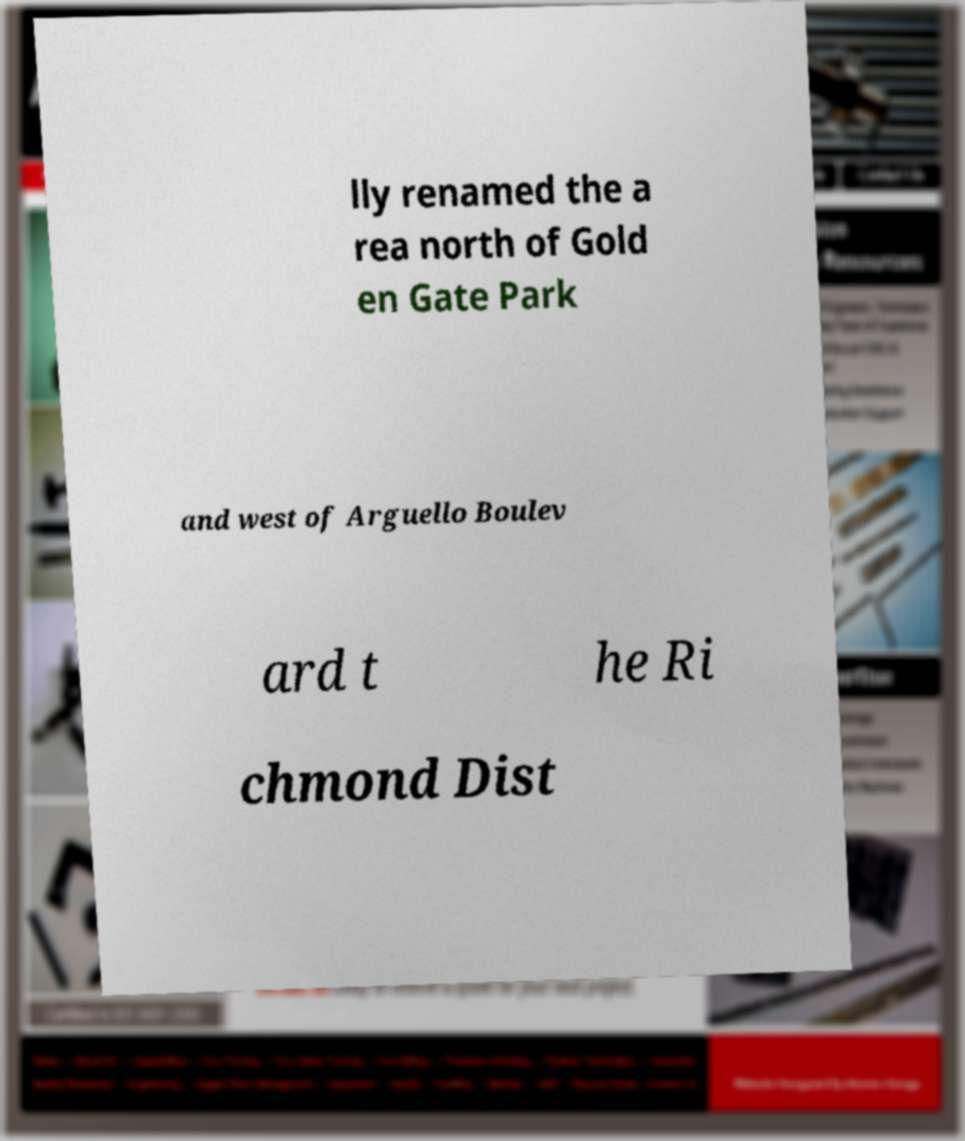Could you extract and type out the text from this image? lly renamed the a rea north of Gold en Gate Park and west of Arguello Boulev ard t he Ri chmond Dist 